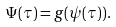<formula> <loc_0><loc_0><loc_500><loc_500>\Psi ( \tau ) = g ( \psi ( \tau ) ) .</formula> 